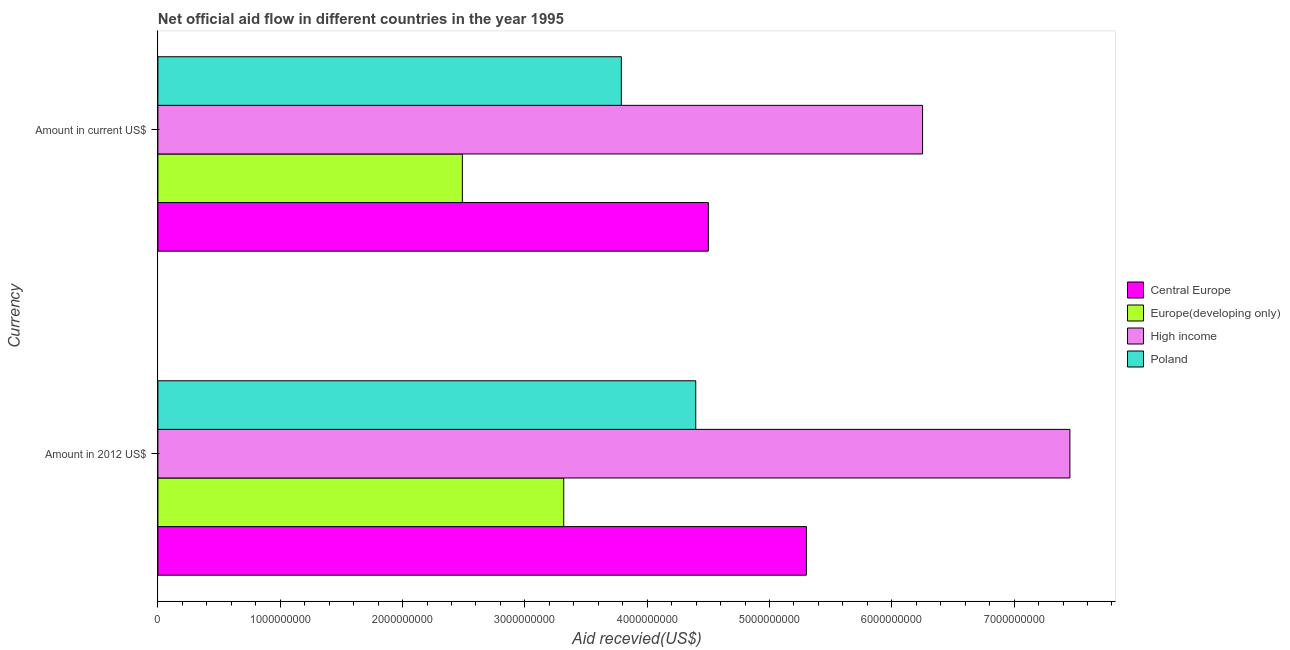Are the number of bars per tick equal to the number of legend labels?
Offer a terse response. Yes. How many bars are there on the 1st tick from the top?
Provide a succinct answer. 4. What is the label of the 1st group of bars from the top?
Your answer should be compact. Amount in current US$. What is the amount of aid received(expressed in 2012 us$) in High income?
Ensure brevity in your answer.  7.46e+09. Across all countries, what is the maximum amount of aid received(expressed in 2012 us$)?
Ensure brevity in your answer.  7.46e+09. Across all countries, what is the minimum amount of aid received(expressed in us$)?
Ensure brevity in your answer.  2.49e+09. In which country was the amount of aid received(expressed in us$) maximum?
Your answer should be very brief. High income. In which country was the amount of aid received(expressed in 2012 us$) minimum?
Your response must be concise. Europe(developing only). What is the total amount of aid received(expressed in 2012 us$) in the graph?
Ensure brevity in your answer.  2.05e+1. What is the difference between the amount of aid received(expressed in us$) in Europe(developing only) and that in Poland?
Keep it short and to the point. -1.30e+09. What is the difference between the amount of aid received(expressed in 2012 us$) in Poland and the amount of aid received(expressed in us$) in High income?
Give a very brief answer. -1.85e+09. What is the average amount of aid received(expressed in 2012 us$) per country?
Your answer should be compact. 5.12e+09. What is the difference between the amount of aid received(expressed in 2012 us$) and amount of aid received(expressed in us$) in Central Europe?
Provide a short and direct response. 8.01e+08. In how many countries, is the amount of aid received(expressed in us$) greater than 6600000000 US$?
Provide a succinct answer. 0. What is the ratio of the amount of aid received(expressed in us$) in Europe(developing only) to that in Poland?
Provide a short and direct response. 0.66. Is the amount of aid received(expressed in us$) in High income less than that in Poland?
Offer a very short reply. No. What does the 2nd bar from the bottom in Amount in current US$ represents?
Ensure brevity in your answer.  Europe(developing only). How many countries are there in the graph?
Offer a terse response. 4. Are the values on the major ticks of X-axis written in scientific E-notation?
Your response must be concise. No. Does the graph contain any zero values?
Provide a succinct answer. No. How many legend labels are there?
Keep it short and to the point. 4. What is the title of the graph?
Provide a succinct answer. Net official aid flow in different countries in the year 1995. What is the label or title of the X-axis?
Your answer should be compact. Aid recevied(US$). What is the label or title of the Y-axis?
Provide a succinct answer. Currency. What is the Aid recevied(US$) in Central Europe in Amount in 2012 US$?
Provide a short and direct response. 5.30e+09. What is the Aid recevied(US$) in Europe(developing only) in Amount in 2012 US$?
Make the answer very short. 3.32e+09. What is the Aid recevied(US$) of High income in Amount in 2012 US$?
Keep it short and to the point. 7.46e+09. What is the Aid recevied(US$) in Poland in Amount in 2012 US$?
Your answer should be compact. 4.40e+09. What is the Aid recevied(US$) of Central Europe in Amount in current US$?
Offer a terse response. 4.50e+09. What is the Aid recevied(US$) of Europe(developing only) in Amount in current US$?
Give a very brief answer. 2.49e+09. What is the Aid recevied(US$) in High income in Amount in current US$?
Provide a short and direct response. 6.25e+09. What is the Aid recevied(US$) of Poland in Amount in current US$?
Ensure brevity in your answer.  3.79e+09. Across all Currency, what is the maximum Aid recevied(US$) in Central Europe?
Make the answer very short. 5.30e+09. Across all Currency, what is the maximum Aid recevied(US$) in Europe(developing only)?
Offer a terse response. 3.32e+09. Across all Currency, what is the maximum Aid recevied(US$) in High income?
Your answer should be compact. 7.46e+09. Across all Currency, what is the maximum Aid recevied(US$) of Poland?
Ensure brevity in your answer.  4.40e+09. Across all Currency, what is the minimum Aid recevied(US$) of Central Europe?
Ensure brevity in your answer.  4.50e+09. Across all Currency, what is the minimum Aid recevied(US$) of Europe(developing only)?
Your answer should be very brief. 2.49e+09. Across all Currency, what is the minimum Aid recevied(US$) of High income?
Your answer should be compact. 6.25e+09. Across all Currency, what is the minimum Aid recevied(US$) of Poland?
Keep it short and to the point. 3.79e+09. What is the total Aid recevied(US$) in Central Europe in the graph?
Your answer should be very brief. 9.80e+09. What is the total Aid recevied(US$) of Europe(developing only) in the graph?
Your response must be concise. 5.81e+09. What is the total Aid recevied(US$) in High income in the graph?
Offer a very short reply. 1.37e+1. What is the total Aid recevied(US$) of Poland in the graph?
Provide a short and direct response. 8.19e+09. What is the difference between the Aid recevied(US$) in Central Europe in Amount in 2012 US$ and that in Amount in current US$?
Make the answer very short. 8.01e+08. What is the difference between the Aid recevied(US$) of Europe(developing only) in Amount in 2012 US$ and that in Amount in current US$?
Your response must be concise. 8.29e+08. What is the difference between the Aid recevied(US$) in High income in Amount in 2012 US$ and that in Amount in current US$?
Offer a very short reply. 1.20e+09. What is the difference between the Aid recevied(US$) of Poland in Amount in 2012 US$ and that in Amount in current US$?
Offer a very short reply. 6.08e+08. What is the difference between the Aid recevied(US$) in Central Europe in Amount in 2012 US$ and the Aid recevied(US$) in Europe(developing only) in Amount in current US$?
Provide a succinct answer. 2.81e+09. What is the difference between the Aid recevied(US$) in Central Europe in Amount in 2012 US$ and the Aid recevied(US$) in High income in Amount in current US$?
Give a very brief answer. -9.50e+08. What is the difference between the Aid recevied(US$) in Central Europe in Amount in 2012 US$ and the Aid recevied(US$) in Poland in Amount in current US$?
Give a very brief answer. 1.51e+09. What is the difference between the Aid recevied(US$) in Europe(developing only) in Amount in 2012 US$ and the Aid recevied(US$) in High income in Amount in current US$?
Keep it short and to the point. -2.93e+09. What is the difference between the Aid recevied(US$) of Europe(developing only) in Amount in 2012 US$ and the Aid recevied(US$) of Poland in Amount in current US$?
Ensure brevity in your answer.  -4.71e+08. What is the difference between the Aid recevied(US$) of High income in Amount in 2012 US$ and the Aid recevied(US$) of Poland in Amount in current US$?
Your answer should be compact. 3.67e+09. What is the average Aid recevied(US$) of Central Europe per Currency?
Your answer should be compact. 4.90e+09. What is the average Aid recevied(US$) of Europe(developing only) per Currency?
Make the answer very short. 2.90e+09. What is the average Aid recevied(US$) in High income per Currency?
Make the answer very short. 6.85e+09. What is the average Aid recevied(US$) in Poland per Currency?
Your answer should be compact. 4.09e+09. What is the difference between the Aid recevied(US$) in Central Europe and Aid recevied(US$) in Europe(developing only) in Amount in 2012 US$?
Give a very brief answer. 1.98e+09. What is the difference between the Aid recevied(US$) of Central Europe and Aid recevied(US$) of High income in Amount in 2012 US$?
Make the answer very short. -2.15e+09. What is the difference between the Aid recevied(US$) in Central Europe and Aid recevied(US$) in Poland in Amount in 2012 US$?
Ensure brevity in your answer.  9.05e+08. What is the difference between the Aid recevied(US$) in Europe(developing only) and Aid recevied(US$) in High income in Amount in 2012 US$?
Your answer should be very brief. -4.14e+09. What is the difference between the Aid recevied(US$) of Europe(developing only) and Aid recevied(US$) of Poland in Amount in 2012 US$?
Your answer should be very brief. -1.08e+09. What is the difference between the Aid recevied(US$) in High income and Aid recevied(US$) in Poland in Amount in 2012 US$?
Provide a succinct answer. 3.06e+09. What is the difference between the Aid recevied(US$) of Central Europe and Aid recevied(US$) of Europe(developing only) in Amount in current US$?
Ensure brevity in your answer.  2.01e+09. What is the difference between the Aid recevied(US$) of Central Europe and Aid recevied(US$) of High income in Amount in current US$?
Provide a short and direct response. -1.75e+09. What is the difference between the Aid recevied(US$) in Central Europe and Aid recevied(US$) in Poland in Amount in current US$?
Your answer should be very brief. 7.12e+08. What is the difference between the Aid recevied(US$) of Europe(developing only) and Aid recevied(US$) of High income in Amount in current US$?
Offer a terse response. -3.76e+09. What is the difference between the Aid recevied(US$) of Europe(developing only) and Aid recevied(US$) of Poland in Amount in current US$?
Provide a short and direct response. -1.30e+09. What is the difference between the Aid recevied(US$) in High income and Aid recevied(US$) in Poland in Amount in current US$?
Keep it short and to the point. 2.46e+09. What is the ratio of the Aid recevied(US$) of Central Europe in Amount in 2012 US$ to that in Amount in current US$?
Ensure brevity in your answer.  1.18. What is the ratio of the Aid recevied(US$) in Europe(developing only) in Amount in 2012 US$ to that in Amount in current US$?
Keep it short and to the point. 1.33. What is the ratio of the Aid recevied(US$) of High income in Amount in 2012 US$ to that in Amount in current US$?
Your answer should be very brief. 1.19. What is the ratio of the Aid recevied(US$) of Poland in Amount in 2012 US$ to that in Amount in current US$?
Offer a very short reply. 1.16. What is the difference between the highest and the second highest Aid recevied(US$) of Central Europe?
Provide a short and direct response. 8.01e+08. What is the difference between the highest and the second highest Aid recevied(US$) in Europe(developing only)?
Keep it short and to the point. 8.29e+08. What is the difference between the highest and the second highest Aid recevied(US$) in High income?
Keep it short and to the point. 1.20e+09. What is the difference between the highest and the second highest Aid recevied(US$) of Poland?
Keep it short and to the point. 6.08e+08. What is the difference between the highest and the lowest Aid recevied(US$) of Central Europe?
Keep it short and to the point. 8.01e+08. What is the difference between the highest and the lowest Aid recevied(US$) of Europe(developing only)?
Offer a very short reply. 8.29e+08. What is the difference between the highest and the lowest Aid recevied(US$) of High income?
Offer a very short reply. 1.20e+09. What is the difference between the highest and the lowest Aid recevied(US$) of Poland?
Keep it short and to the point. 6.08e+08. 